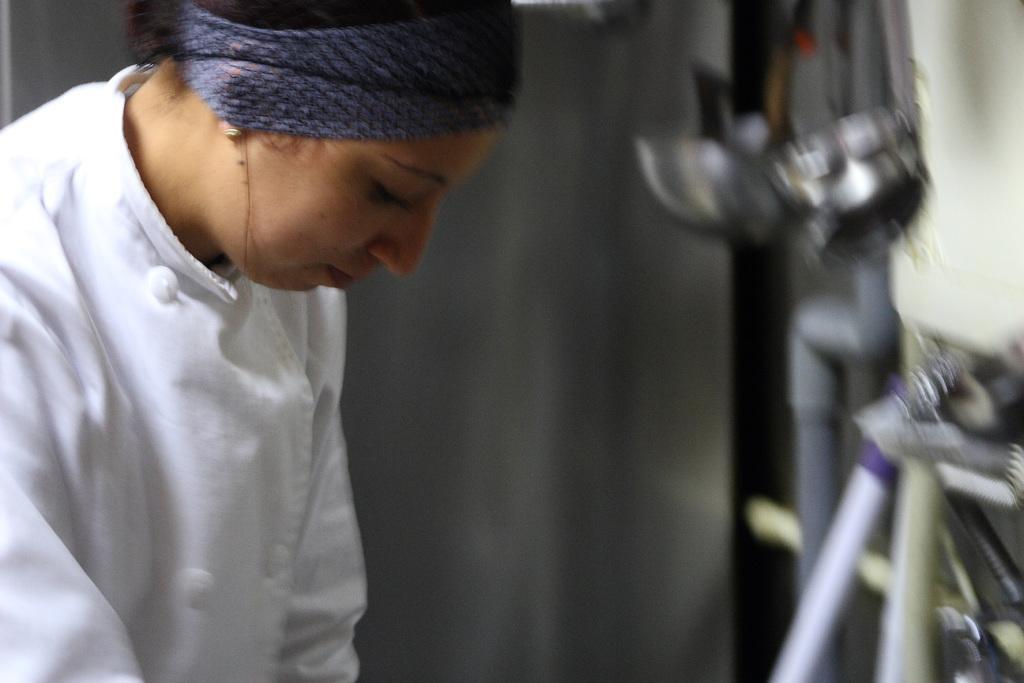Could you give a brief overview of what you see in this image? In this image I can see a person standing wearing white color dress and I can see blurred background. 